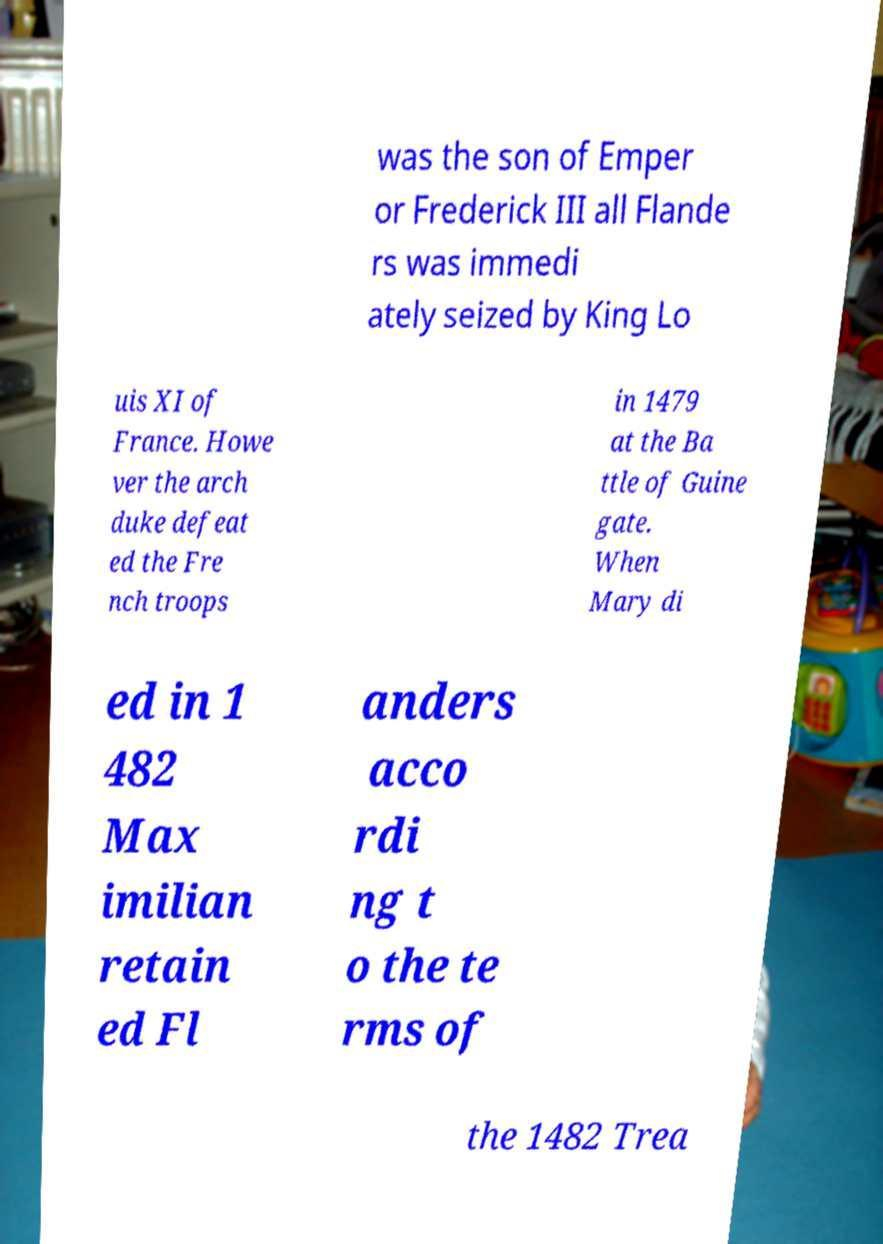Please read and relay the text visible in this image. What does it say? was the son of Emper or Frederick III all Flande rs was immedi ately seized by King Lo uis XI of France. Howe ver the arch duke defeat ed the Fre nch troops in 1479 at the Ba ttle of Guine gate. When Mary di ed in 1 482 Max imilian retain ed Fl anders acco rdi ng t o the te rms of the 1482 Trea 